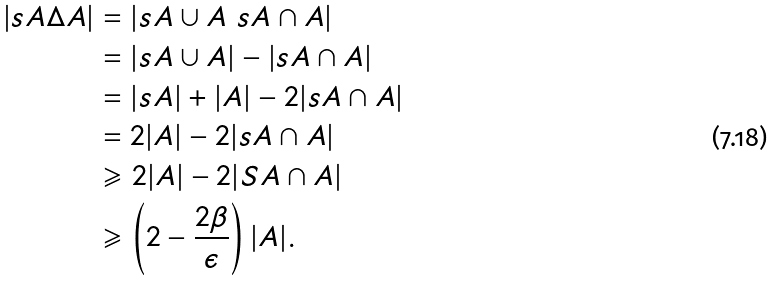Convert formula to latex. <formula><loc_0><loc_0><loc_500><loc_500>| s A \Delta A | & = | s A \cup A \ s A \cap A | \\ & = | s A \cup A | - | s A \cap A | \\ & = | s A | + | A | - 2 | s A \cap A | \\ & = 2 | A | - 2 | s A \cap A | \\ & \geqslant 2 | A | - 2 | S A \cap A | \\ & \geqslant \left ( 2 - \frac { 2 \beta } { \epsilon } \right ) | A | .</formula> 